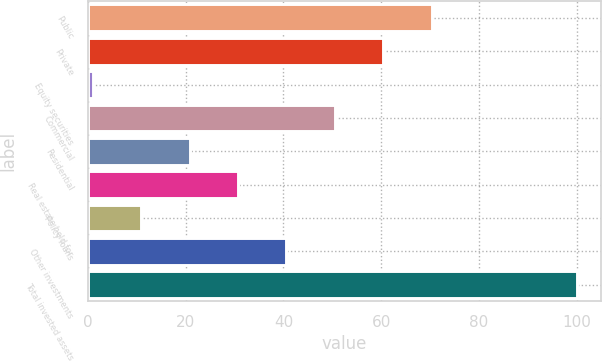Convert chart. <chart><loc_0><loc_0><loc_500><loc_500><bar_chart><fcel>Public<fcel>Private<fcel>Equity securities<fcel>Commercial<fcel>Residential<fcel>Real estate held for<fcel>Policy loans<fcel>Other investments<fcel>Total invested assets<nl><fcel>70.3<fcel>60.4<fcel>1<fcel>50.5<fcel>20.8<fcel>30.7<fcel>10.9<fcel>40.6<fcel>100<nl></chart> 